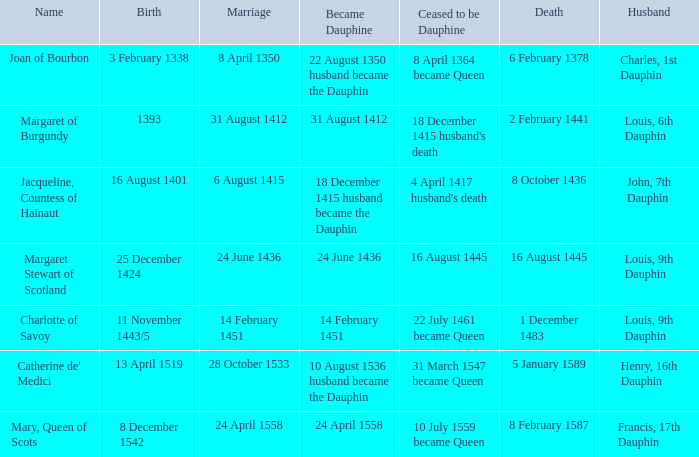When was the title of dauphine given to someone born in 1393? 31 August 1412. I'm looking to parse the entire table for insights. Could you assist me with that? {'header': ['Name', 'Birth', 'Marriage', 'Became Dauphine', 'Ceased to be Dauphine', 'Death', 'Husband'], 'rows': [['Joan of Bourbon', '3 February 1338', '8 April 1350', '22 August 1350 husband became the Dauphin', '8 April 1364 became Queen', '6 February 1378', 'Charles, 1st Dauphin'], ['Margaret of Burgundy', '1393', '31 August 1412', '31 August 1412', "18 December 1415 husband's death", '2 February 1441', 'Louis, 6th Dauphin'], ['Jacqueline, Countess of Hainaut', '16 August 1401', '6 August 1415', '18 December 1415 husband became the Dauphin', "4 April 1417 husband's death", '8 October 1436', 'John, 7th Dauphin'], ['Margaret Stewart of Scotland', '25 December 1424', '24 June 1436', '24 June 1436', '16 August 1445', '16 August 1445', 'Louis, 9th Dauphin'], ['Charlotte of Savoy', '11 November 1443/5', '14 February 1451', '14 February 1451', '22 July 1461 became Queen', '1 December 1483', 'Louis, 9th Dauphin'], ["Catherine de' Medici", '13 April 1519', '28 October 1533', '10 August 1536 husband became the Dauphin', '31 March 1547 became Queen', '5 January 1589', 'Henry, 16th Dauphin'], ['Mary, Queen of Scots', '8 December 1542', '24 April 1558', '24 April 1558', '10 July 1559 became Queen', '8 February 1587', 'Francis, 17th Dauphin']]} 